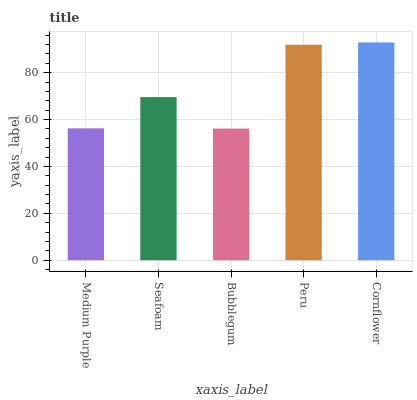Is Bubblegum the minimum?
Answer yes or no. Yes. Is Cornflower the maximum?
Answer yes or no. Yes. Is Seafoam the minimum?
Answer yes or no. No. Is Seafoam the maximum?
Answer yes or no. No. Is Seafoam greater than Medium Purple?
Answer yes or no. Yes. Is Medium Purple less than Seafoam?
Answer yes or no. Yes. Is Medium Purple greater than Seafoam?
Answer yes or no. No. Is Seafoam less than Medium Purple?
Answer yes or no. No. Is Seafoam the high median?
Answer yes or no. Yes. Is Seafoam the low median?
Answer yes or no. Yes. Is Peru the high median?
Answer yes or no. No. Is Bubblegum the low median?
Answer yes or no. No. 